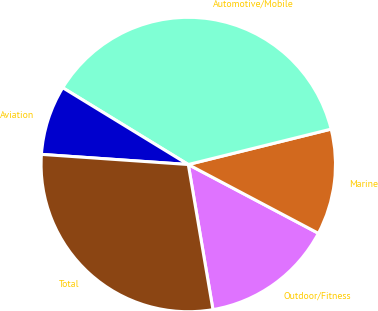Convert chart. <chart><loc_0><loc_0><loc_500><loc_500><pie_chart><fcel>Outdoor/Fitness<fcel>Marine<fcel>Automotive/Mobile<fcel>Aviation<fcel>Total<nl><fcel>14.58%<fcel>11.61%<fcel>37.4%<fcel>7.64%<fcel>28.78%<nl></chart> 